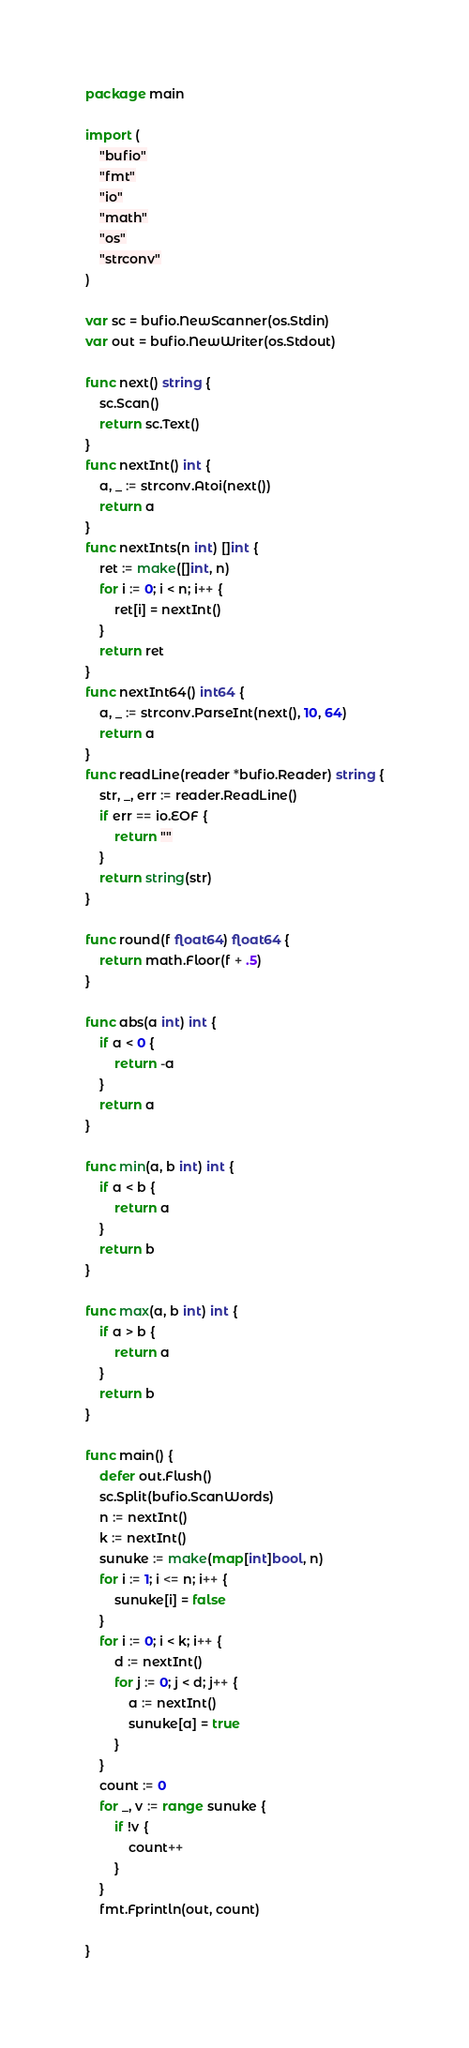Convert code to text. <code><loc_0><loc_0><loc_500><loc_500><_Go_>package main

import (
	"bufio"
	"fmt"
	"io"
	"math"
	"os"
	"strconv"
)

var sc = bufio.NewScanner(os.Stdin)
var out = bufio.NewWriter(os.Stdout)

func next() string {
	sc.Scan()
	return sc.Text()
}
func nextInt() int {
	a, _ := strconv.Atoi(next())
	return a
}
func nextInts(n int) []int {
	ret := make([]int, n)
	for i := 0; i < n; i++ {
		ret[i] = nextInt()
	}
	return ret
}
func nextInt64() int64 {
	a, _ := strconv.ParseInt(next(), 10, 64)
	return a
}
func readLine(reader *bufio.Reader) string {
	str, _, err := reader.ReadLine()
	if err == io.EOF {
		return ""
	}
	return string(str)
}

func round(f float64) float64 {
	return math.Floor(f + .5)
}

func abs(a int) int {
	if a < 0 {
		return -a
	}
	return a
}

func min(a, b int) int {
	if a < b {
		return a
	}
	return b
}

func max(a, b int) int {
	if a > b {
		return a
	}
	return b
}

func main() {
	defer out.Flush()
	sc.Split(bufio.ScanWords)
	n := nextInt()
	k := nextInt()
	sunuke := make(map[int]bool, n)
	for i := 1; i <= n; i++ {
		sunuke[i] = false
	}
	for i := 0; i < k; i++ {
		d := nextInt()
		for j := 0; j < d; j++ {
			a := nextInt()
			sunuke[a] = true
		}
	}
	count := 0
	for _, v := range sunuke {
		if !v {
			count++
		}
	}
	fmt.Fprintln(out, count)

}
</code> 